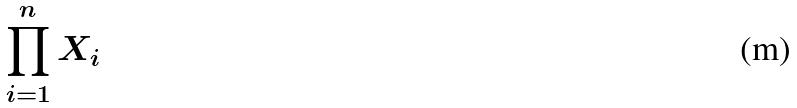Convert formula to latex. <formula><loc_0><loc_0><loc_500><loc_500>\prod _ { i = 1 } ^ { n } X _ { i }</formula> 